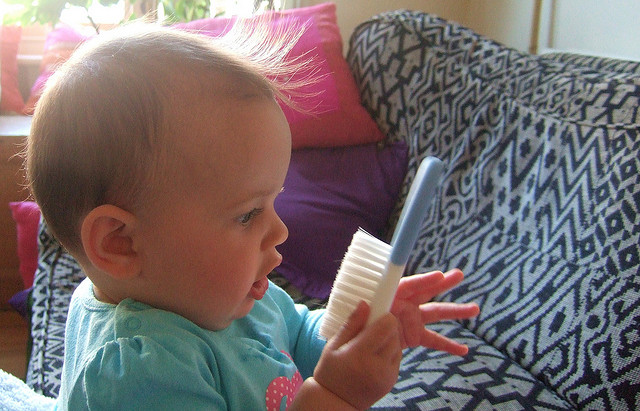How might the texture of the hairbrush contribute to sensory development in infants? The texture of the hairbrush may intrigue the baby, as different textures stimulate sensory development by invoking responses to varied tactile experiences. Engaging with textured objects helps infants build neural connections, and understand and categorize different sensations, which is crucial for cognitive and sensory development. 